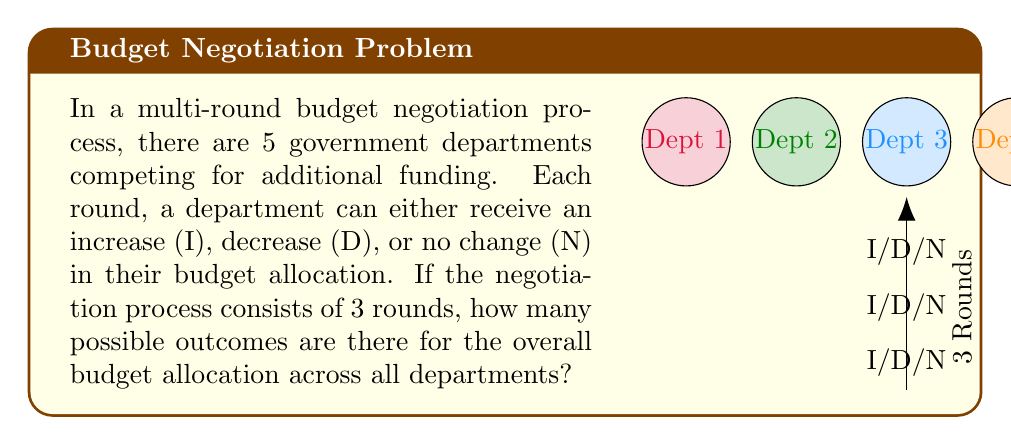Solve this math problem. Let's approach this step-by-step:

1) For each department in each round, there are 3 possible outcomes: Increase (I), Decrease (D), or No change (N).

2) We have 5 departments and 3 rounds of negotiations.

3) For each department, we need to determine the number of possible outcomes across all 3 rounds. This is equivalent to making 3 independent choices, each with 3 options. Therefore, for each department, the number of possibilities is:

   $3 \times 3 \times 3 = 3^3 = 27$

4) Now, we need to consider this for all 5 departments. Since the outcome for each department is independent of the others, we multiply the possibilities for each department:

   $27 \times 27 \times 27 \times 27 \times 27 = 27^5$

5) We can simplify this further:

   $27^5 = (3^3)^5 = 3^{15}$

Therefore, the total number of possible outcomes is $3^{15}$.

To calculate this:

$3^{15} = 14,348,907$

This large number reflects the complexity of budget negotiations across multiple departments and rounds, which aligns with the congressional aide's perspective on the intricacy of resource allocation among government departments.
Answer: $3^{15} = 14,348,907$ 